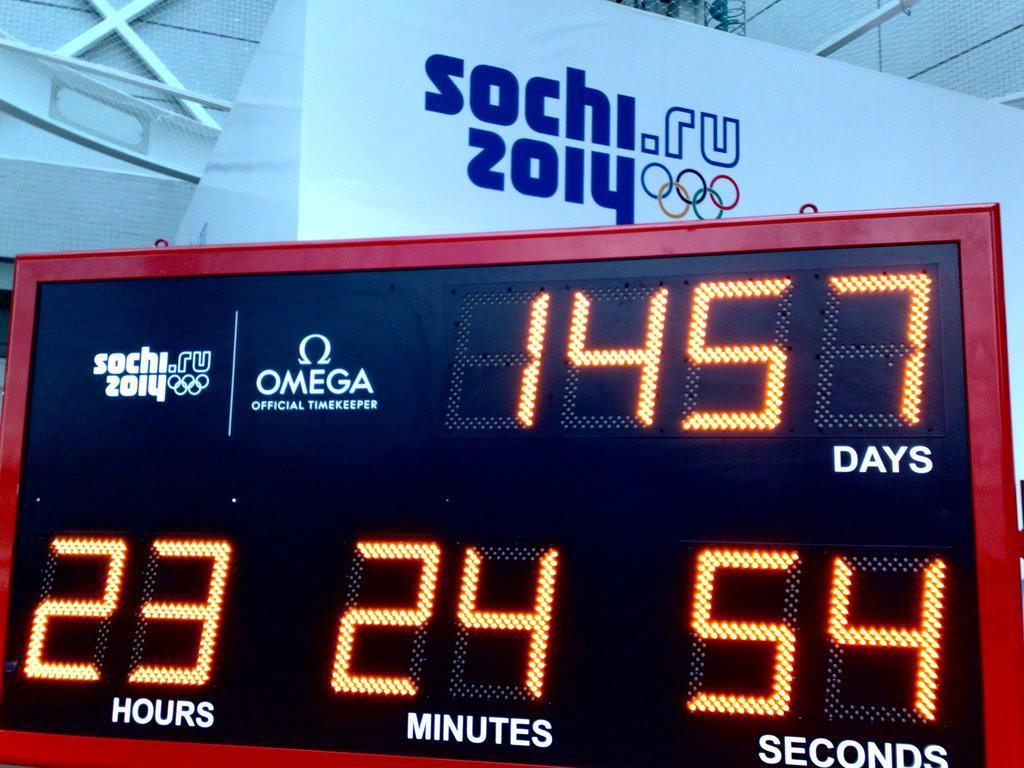Which watch company is the official timekeeper?
Offer a terse response. Omega. 